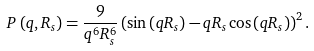<formula> <loc_0><loc_0><loc_500><loc_500>P \left ( q , R _ { s } \right ) = \frac { 9 } { q ^ { 6 } R _ { s } ^ { 6 } } \left ( \sin \left ( q R _ { s } \right ) - q R _ { s } \cos \left ( q R _ { s } \right ) \right ) ^ { 2 } .</formula> 